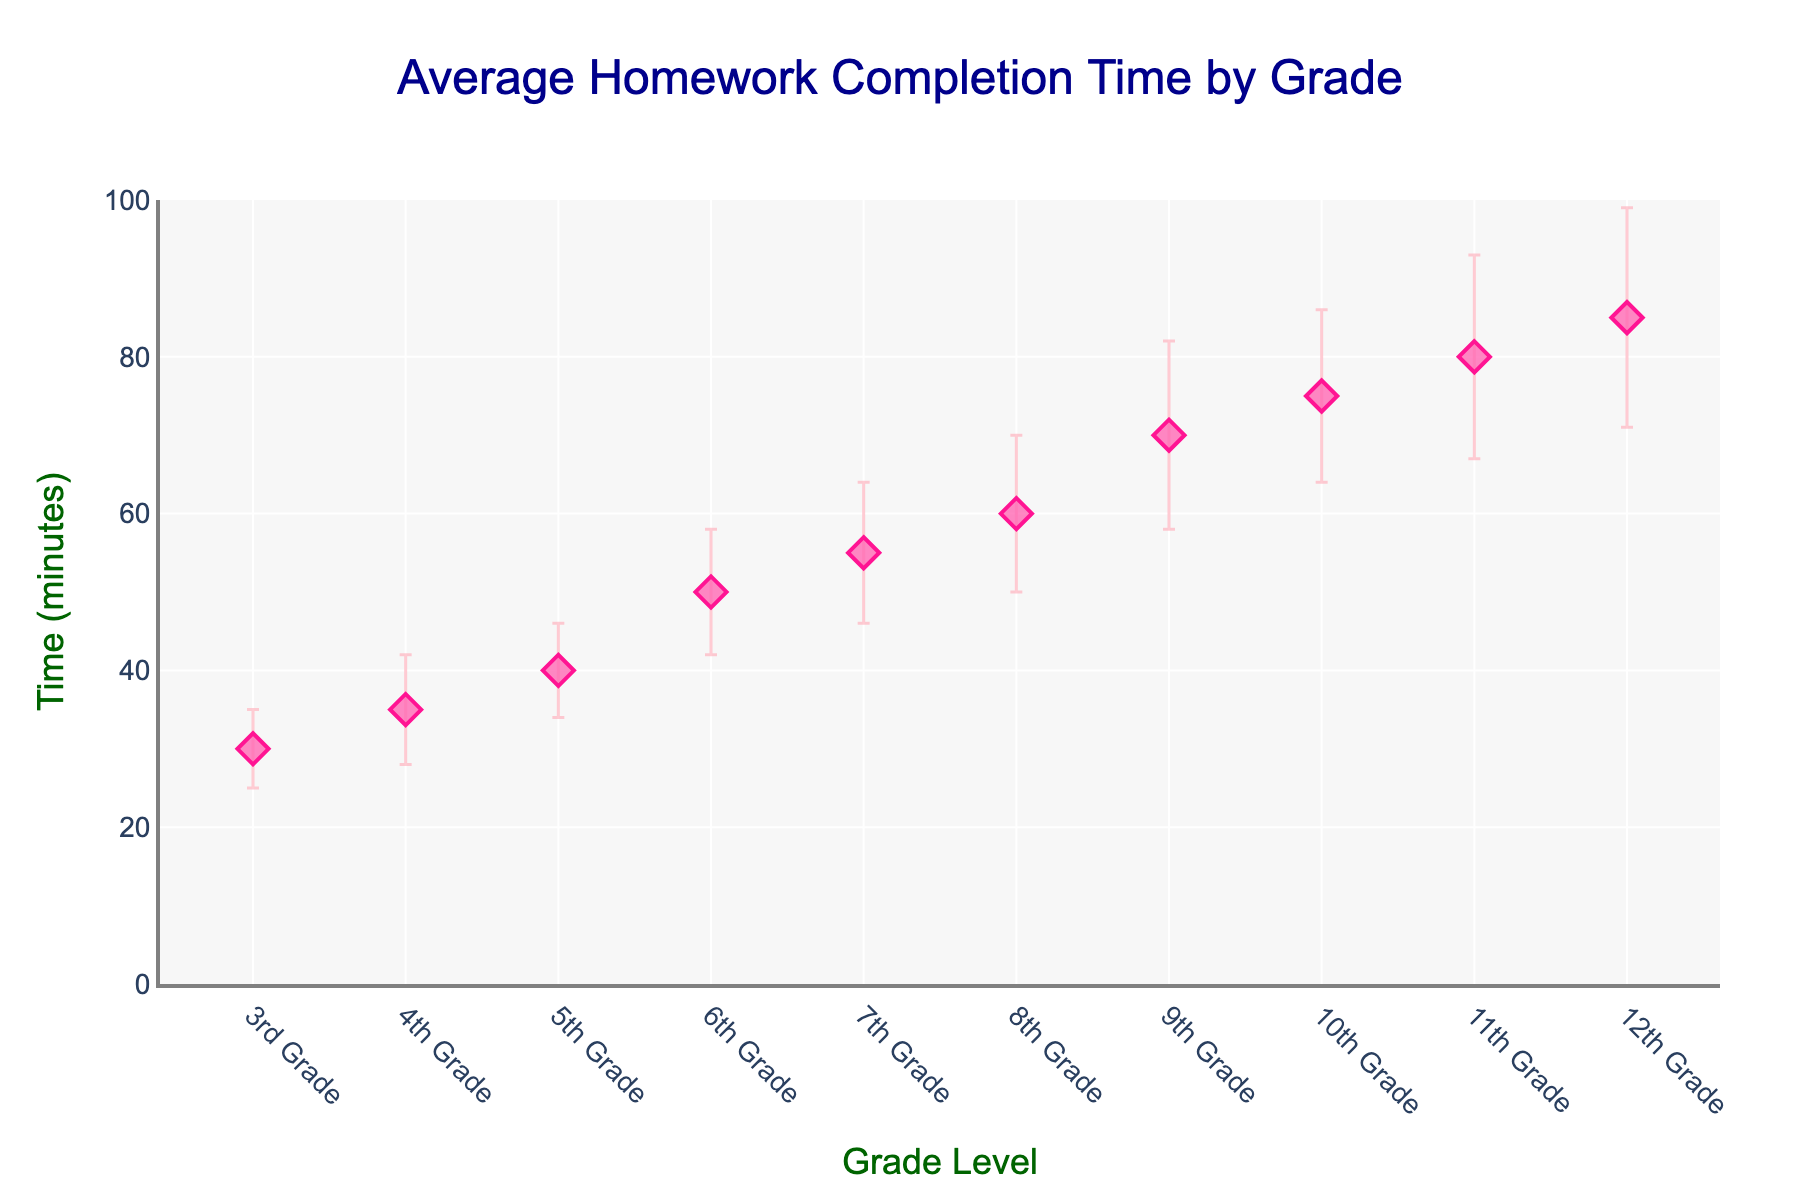What is the title of the figure? The title is located at the top of the figure, usually in large font size for prominence. It summarizes the main idea of the plot.
Answer: Average Homework Completion Time by Grade What does the y-axis represent? The y-axis is labeled with the metric it measures, and it runs vertically along the left side of the plot.
Answer: Time (minutes) Which grade has the highest average homework completion time? To determine this, look for the highest dot on the y-axis representing average homework completion time.
Answer: 12th Grade What is the average homework completion time for 6th Grade? Find the dot corresponding to 6th Grade on the x-axis, then check its value on the y-axis.
Answer: 50 minutes How do the error bars for 10th Grade compare to those for 9th Grade in terms of length? Examine the length of the error bars for both grades, noting that longer bars represent greater standard deviation.
Answer: 10th Grade's error bars are shorter than 9th Grade's By how many minutes is the average homework completion time higher in 8th Grade compared to 5th Grade? Subtract the average time for 5th Grade from that of 8th Grade according to the y-axis values.
Answer: 20 minutes Which grade has the smallest standard deviation? Identify the grade with the shortest error bar, indicating the smallest standard deviation.
Answer: 3rd Grade What is the sum of the average homework completion times for 3rd and 9th Grades? Add the average values of 3rd and 9th Grades based on their y-axis positions.
Answer: 100 minutes On which grade does the standard deviation exceed 10 minutes? Look for grades with error bars extending above 10 units on either side from the dot representing the average.
Answer: 9th, 11th, and 12th Grades 